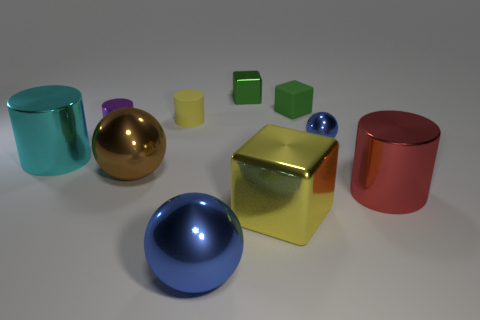There is a large block that is made of the same material as the tiny purple cylinder; what is its color?
Keep it short and to the point. Yellow. Is the number of tiny matte cylinders that are in front of the large cyan metallic thing less than the number of large blue rubber balls?
Your response must be concise. No. The brown object that is made of the same material as the big cyan cylinder is what shape?
Give a very brief answer. Sphere. What number of rubber objects are either gray blocks or brown balls?
Offer a terse response. 0. Are there the same number of yellow cubes behind the yellow cylinder and green matte cylinders?
Your answer should be compact. Yes. Do the block in front of the big brown ball and the small sphere have the same color?
Keep it short and to the point. No. What is the material of the cylinder that is both in front of the tiny shiny ball and on the left side of the small yellow rubber cylinder?
Offer a terse response. Metal. There is a big cylinder that is to the left of the red metal cylinder; are there any large objects behind it?
Your answer should be very brief. No. Is the tiny yellow thing made of the same material as the cyan cylinder?
Your answer should be compact. No. What shape is the tiny metal thing that is in front of the green metallic cube and on the left side of the small blue ball?
Ensure brevity in your answer.  Cylinder. 